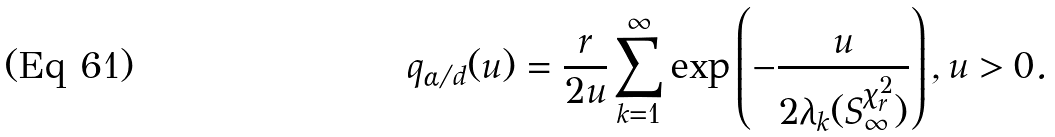Convert formula to latex. <formula><loc_0><loc_0><loc_500><loc_500>q _ { \alpha / d } ( u ) = \frac { r } { 2 u } \sum _ { k = 1 } ^ { \infty } \exp \left ( - \frac { u } { 2 \lambda _ { k } ( S _ { \infty } ^ { \chi ^ { 2 } _ { r } } ) } \right ) , u > 0 .</formula> 